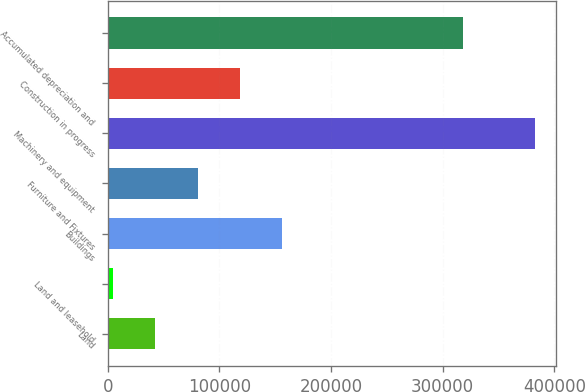Convert chart. <chart><loc_0><loc_0><loc_500><loc_500><bar_chart><fcel>Land<fcel>Land and leasehold<fcel>Buildings<fcel>Furniture and Fixtures<fcel>Machinery and equipment<fcel>Construction in progress<fcel>Accumulated depreciation and<nl><fcel>42748.3<fcel>4989<fcel>156026<fcel>80507.6<fcel>382582<fcel>118267<fcel>318076<nl></chart> 